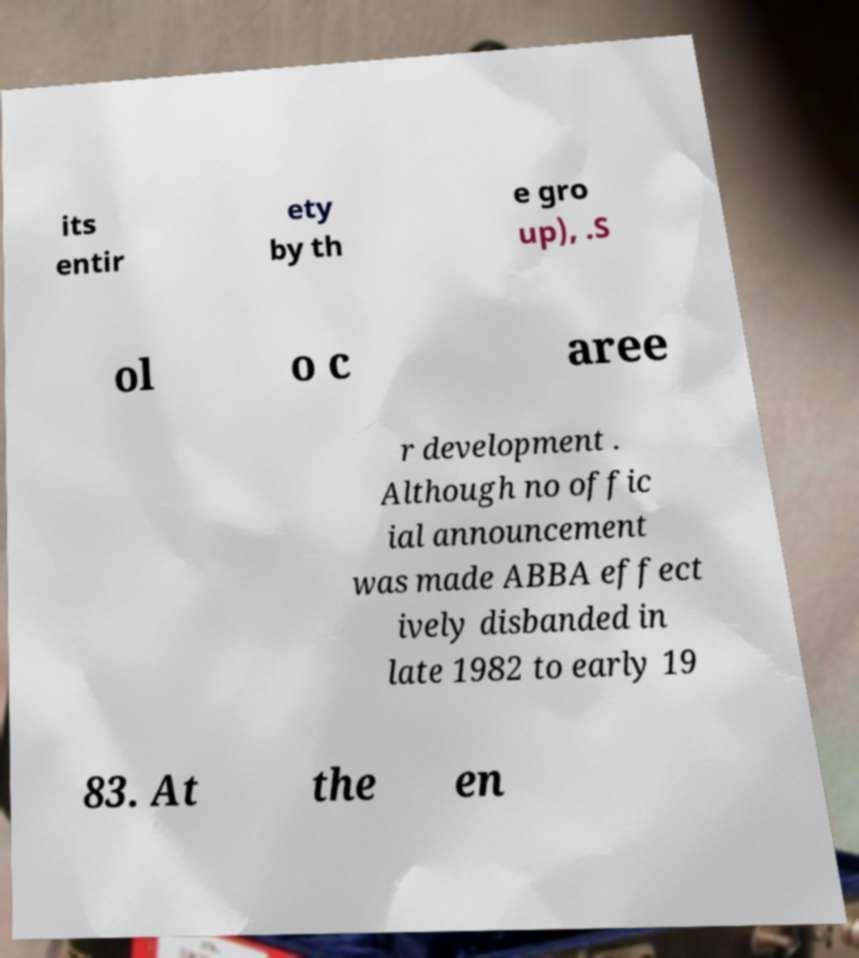Please read and relay the text visible in this image. What does it say? its entir ety by th e gro up), .S ol o c aree r development . Although no offic ial announcement was made ABBA effect ively disbanded in late 1982 to early 19 83. At the en 